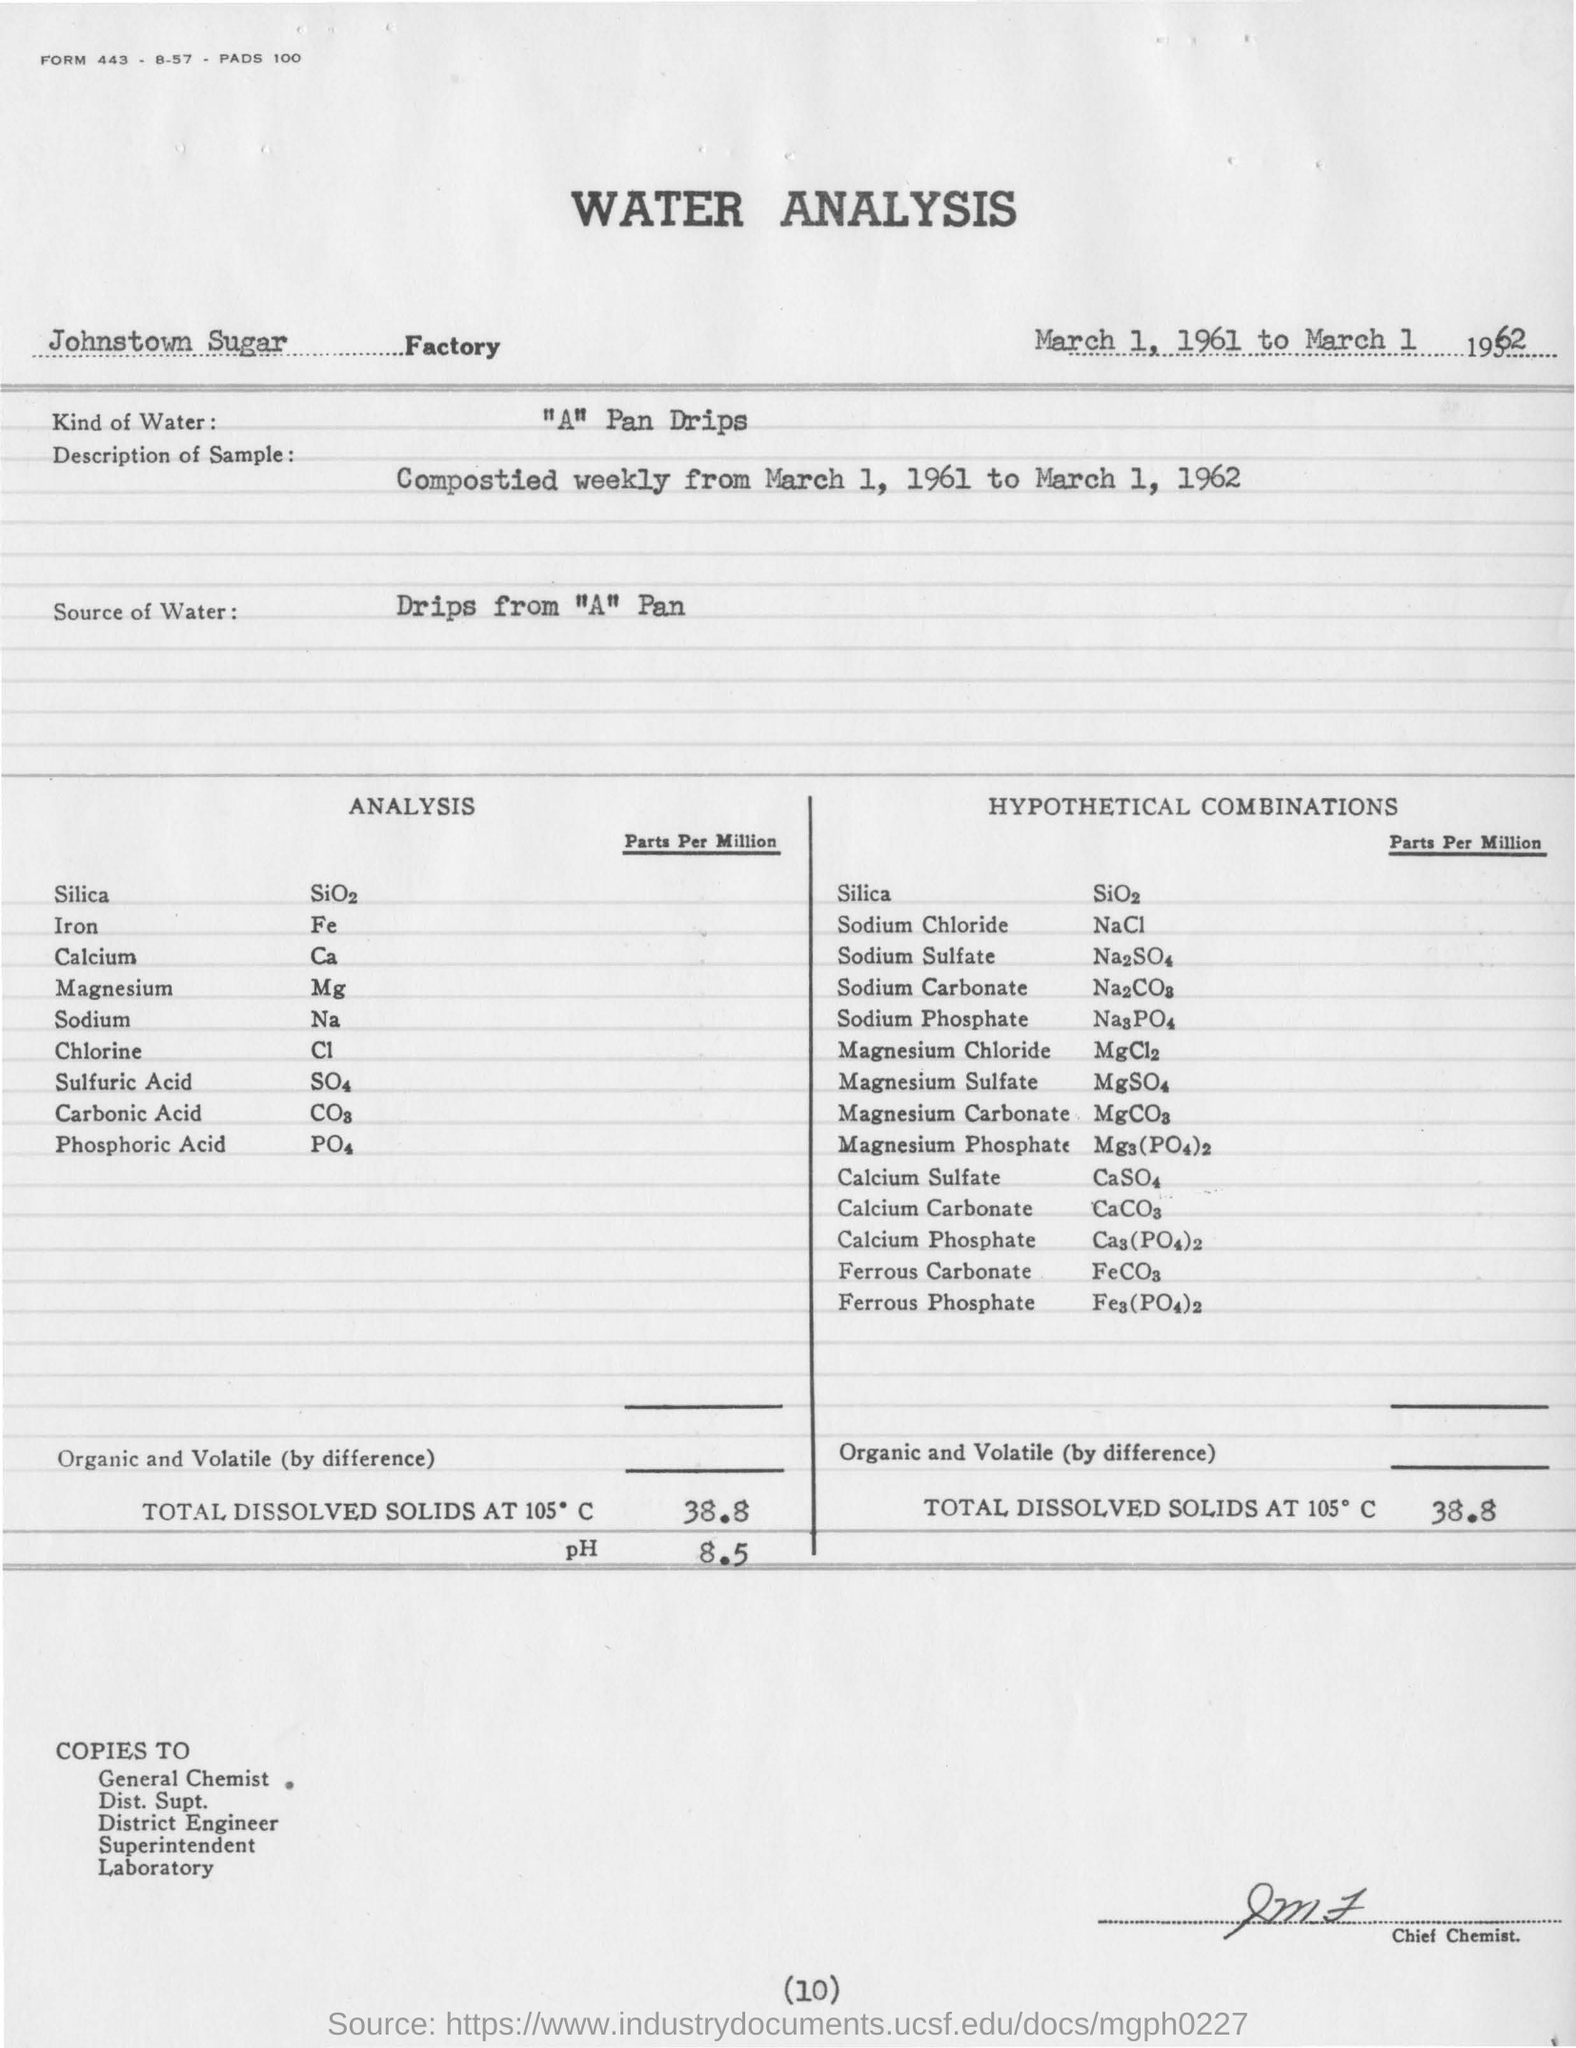Give some essential details in this illustration. The water droplets originating from the "A" pan are intended for water analysis, with the source of the water unknown. The pH value obtained from the water analysis was 8.5. The water analysis is conducted in Johnstown Sugar Factory. The amount of total dissolved solids at 105 degrees Celsius is 38.8... Water of a specific type, commonly referred to as "Pan Drips," is typically used in the process of water analysis. 